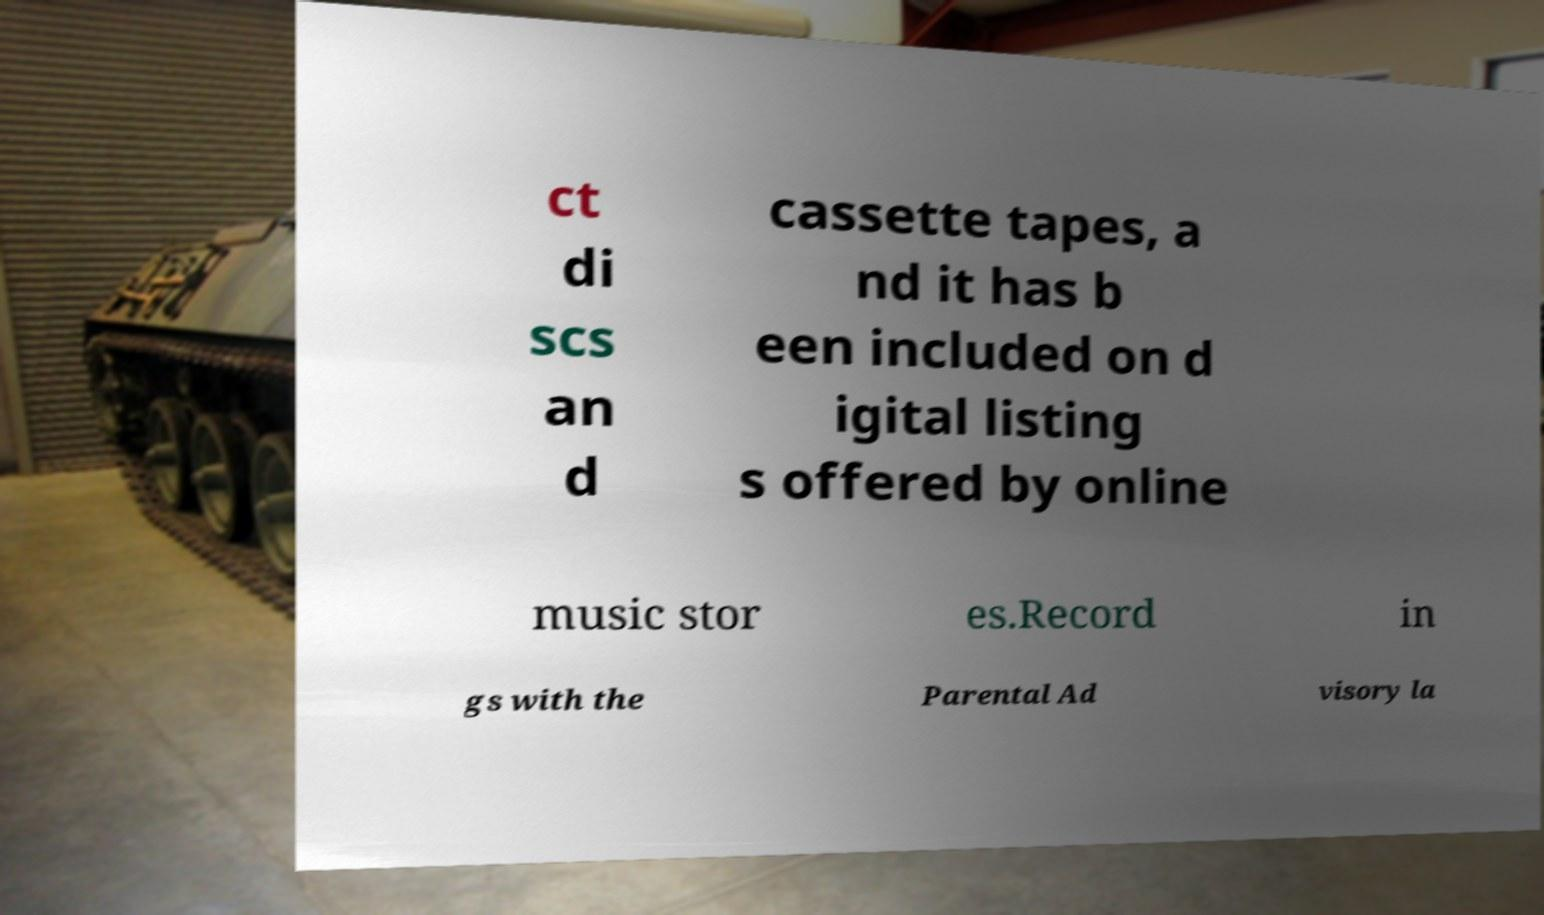Could you assist in decoding the text presented in this image and type it out clearly? ct di scs an d cassette tapes, a nd it has b een included on d igital listing s offered by online music stor es.Record in gs with the Parental Ad visory la 